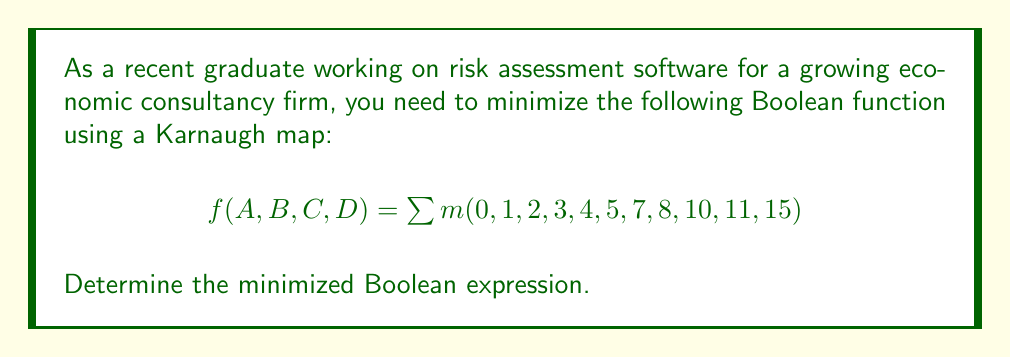Provide a solution to this math problem. Let's approach this step-by-step:

1) First, we need to create a 4-variable Karnaugh map:

[asy]
unitsize(1cm);
draw(box((0,0),(4,4)));
draw((0,1)--(4,1));
draw((0,2)--(4,2));
draw((0,3)--(4,3));
draw((1,0)--(1,4));
draw((2,0)--(2,4));
draw((3,0)--(3,4));
label("00", (0.5,3.5));
label("01", (1.5,3.5));
label("11", (2.5,3.5));
label("10", (3.5,3.5));
label("00", (-0.5,3.5));
label("01", (-0.5,2.5));
label("11", (-0.5,1.5));
label("10", (-0.5,0.5));
label("AB", (-0.5,4.5));
label("CD", (0.5,4.5));
label("1", (0.5,3.5));
label("1", (1.5,3.5));
label("1", (2.5,3.5));
label("1", (3.5,3.5));
label("1", (0.5,2.5));
label("1", (1.5,2.5));
label("0", (2.5,2.5));
label("1", (3.5,2.5));
label("0", (0.5,1.5));
label("1", (1.5,1.5));
label("1", (2.5,1.5));
label("0", (3.5,1.5));
label("1", (0.5,0.5));
label("0", (1.5,0.5));
label("1", (2.5,0.5));
label("0", (3.5,0.5));
[/asy]

2) Now, we need to identify the largest possible groups of 1s:
   - There's a group of 4 in the top row: $\bar{C}\bar{D}$
   - There's a group of 4 in the left column: $\bar{A}\bar{B}$
   - There's a group of 4 in the corners: $\bar{B}D + BD$, which simplifies to $D$
   - There's a group of 2 in the middle right: $AB\bar{C}$

3) The minimized function is the OR of all these groups:

   $f(A,B,C,D) = \bar{C}\bar{D} + \bar{A}\bar{B} + D + AB\bar{C}$

4) This can be further simplified:
   $f(A,B,C,D) = \bar{C}\bar{D} + \bar{A}\bar{B} + D$

   The term $AB\bar{C}$ is redundant because it's already covered by $\bar{C}\bar{D} + D$.
Answer: $f(A,B,C,D) = \bar{C}\bar{D} + \bar{A}\bar{B} + D$ 